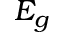<formula> <loc_0><loc_0><loc_500><loc_500>E _ { g }</formula> 